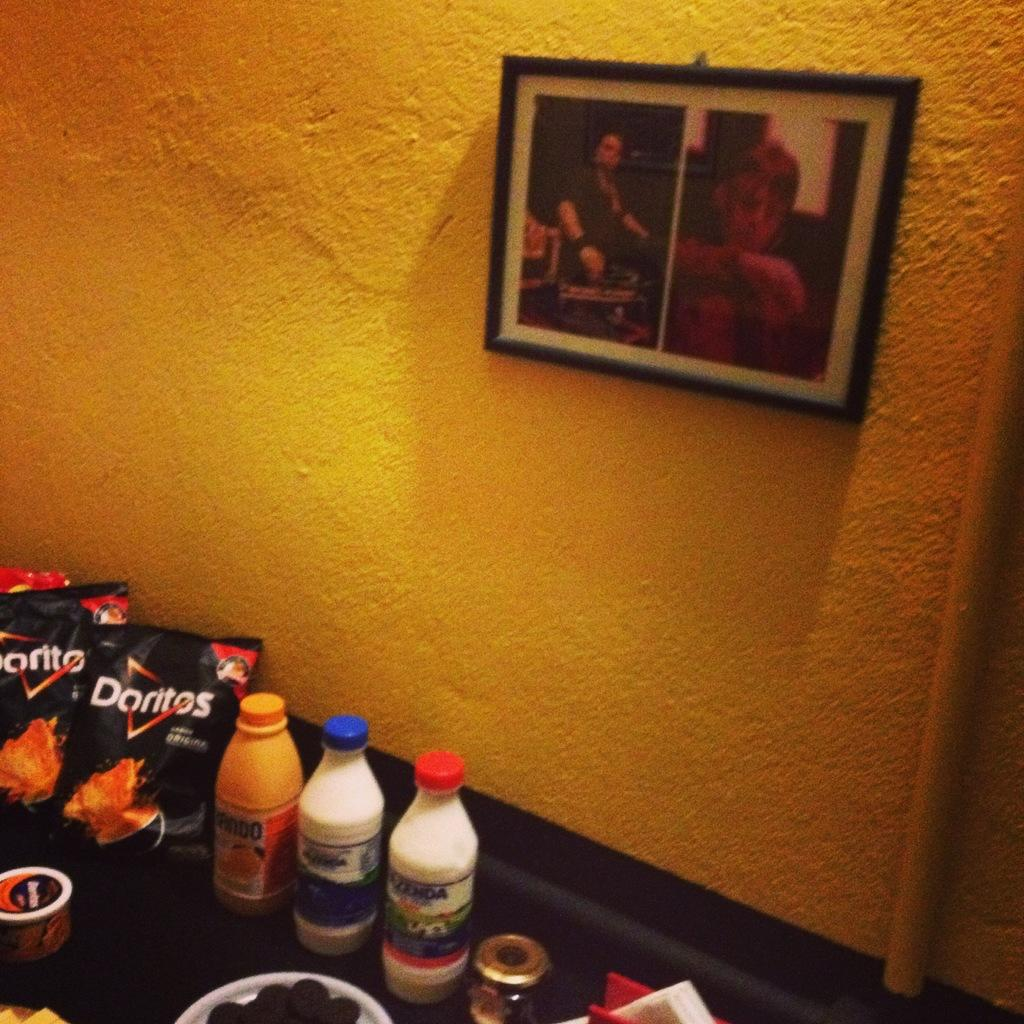<image>
Share a concise interpretation of the image provided. On the table is a collection of drinks and snacks including doritos. 